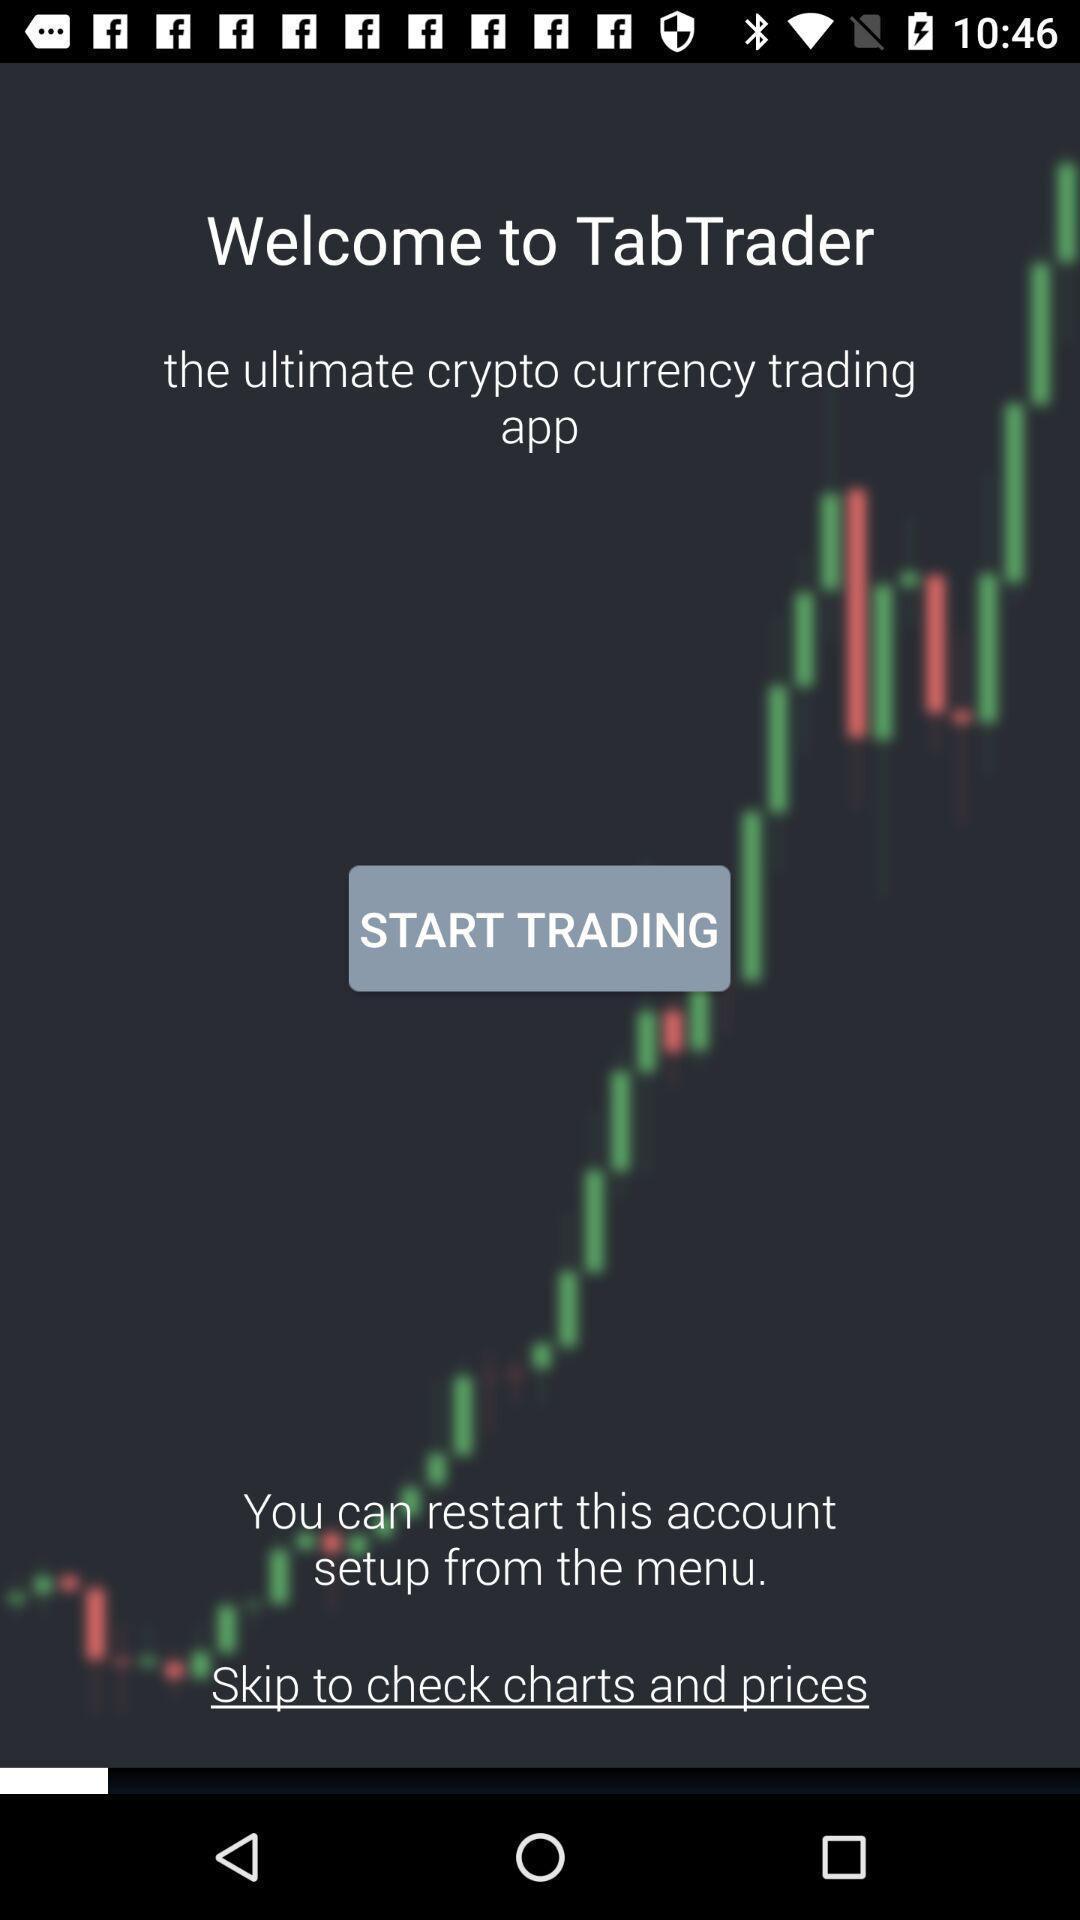Give me a summary of this screen capture. Welcome page with start option. 